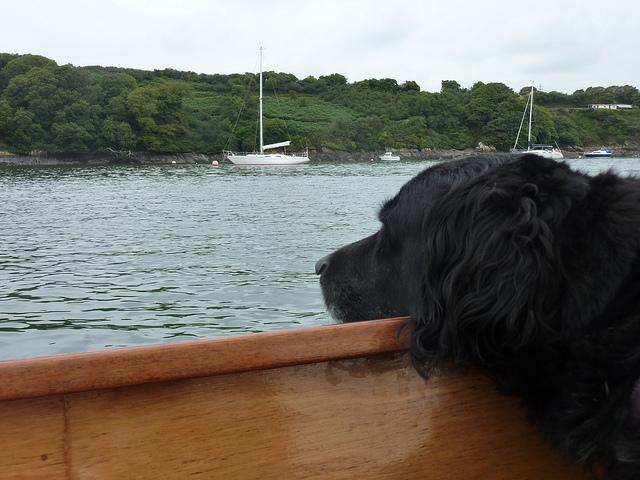What is causing the dog to rest his head on the side of the boat? Please explain your reasoning. boredom. The dog is bored and is looking forward. 